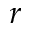Convert formula to latex. <formula><loc_0><loc_0><loc_500><loc_500>r</formula> 